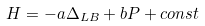<formula> <loc_0><loc_0><loc_500><loc_500>H = - a \Delta _ { L B } + b P + c o n s t</formula> 